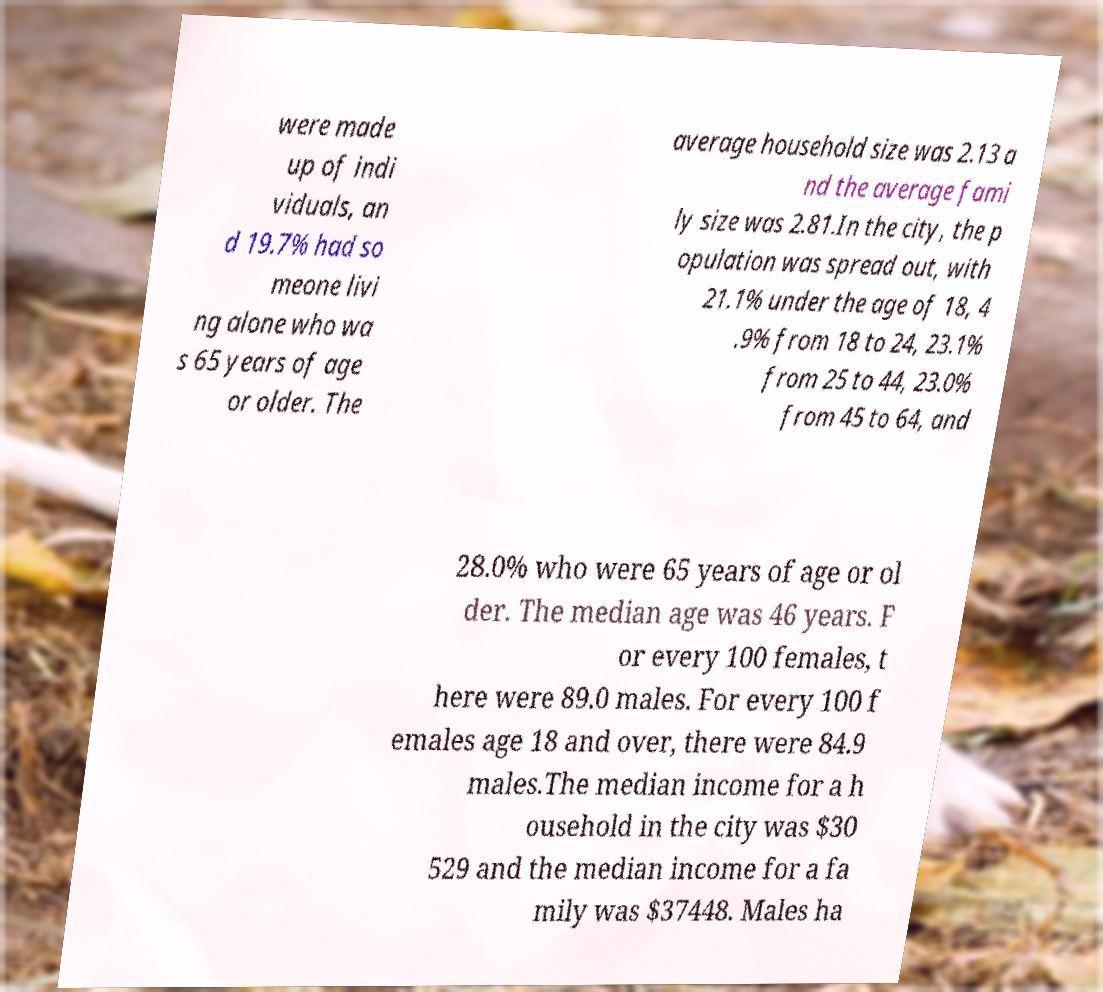Can you read and provide the text displayed in the image?This photo seems to have some interesting text. Can you extract and type it out for me? were made up of indi viduals, an d 19.7% had so meone livi ng alone who wa s 65 years of age or older. The average household size was 2.13 a nd the average fami ly size was 2.81.In the city, the p opulation was spread out, with 21.1% under the age of 18, 4 .9% from 18 to 24, 23.1% from 25 to 44, 23.0% from 45 to 64, and 28.0% who were 65 years of age or ol der. The median age was 46 years. F or every 100 females, t here were 89.0 males. For every 100 f emales age 18 and over, there were 84.9 males.The median income for a h ousehold in the city was $30 529 and the median income for a fa mily was $37448. Males ha 